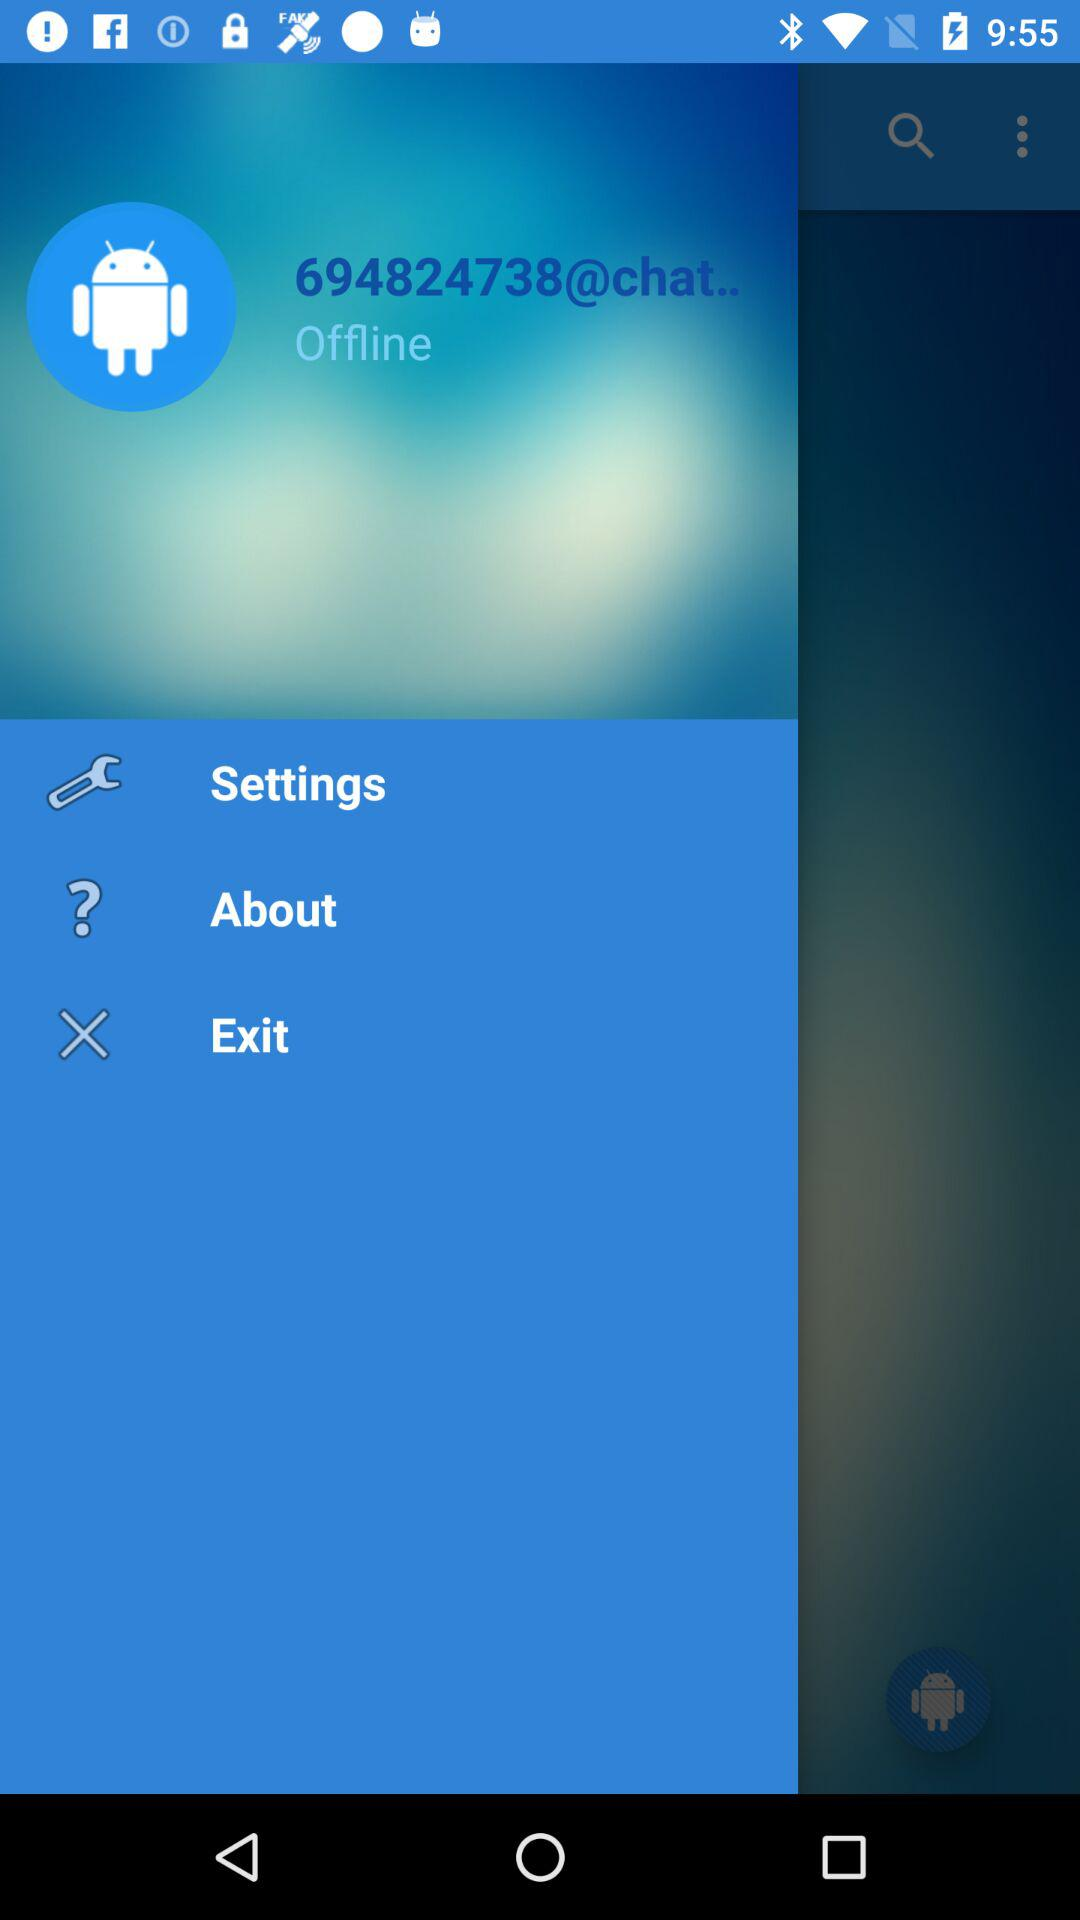What is the status of the user? The status is "Offline". 